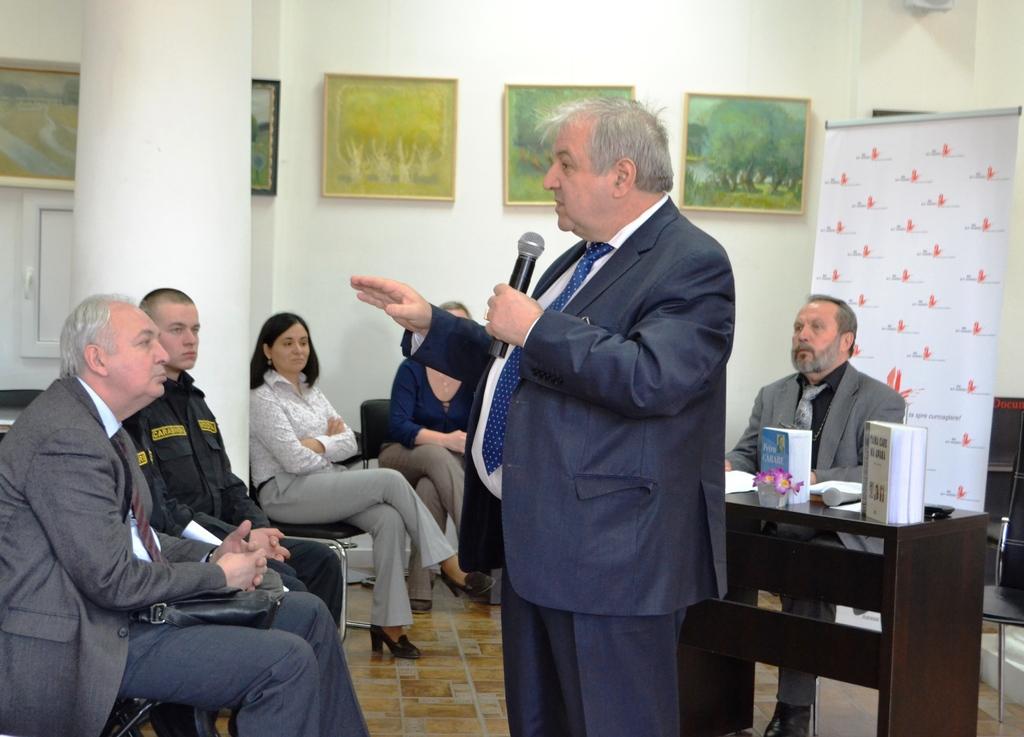Could you give a brief overview of what you see in this image? A man is standing and speaking with a mic in his hand. There are few people around him sitting and listening. 